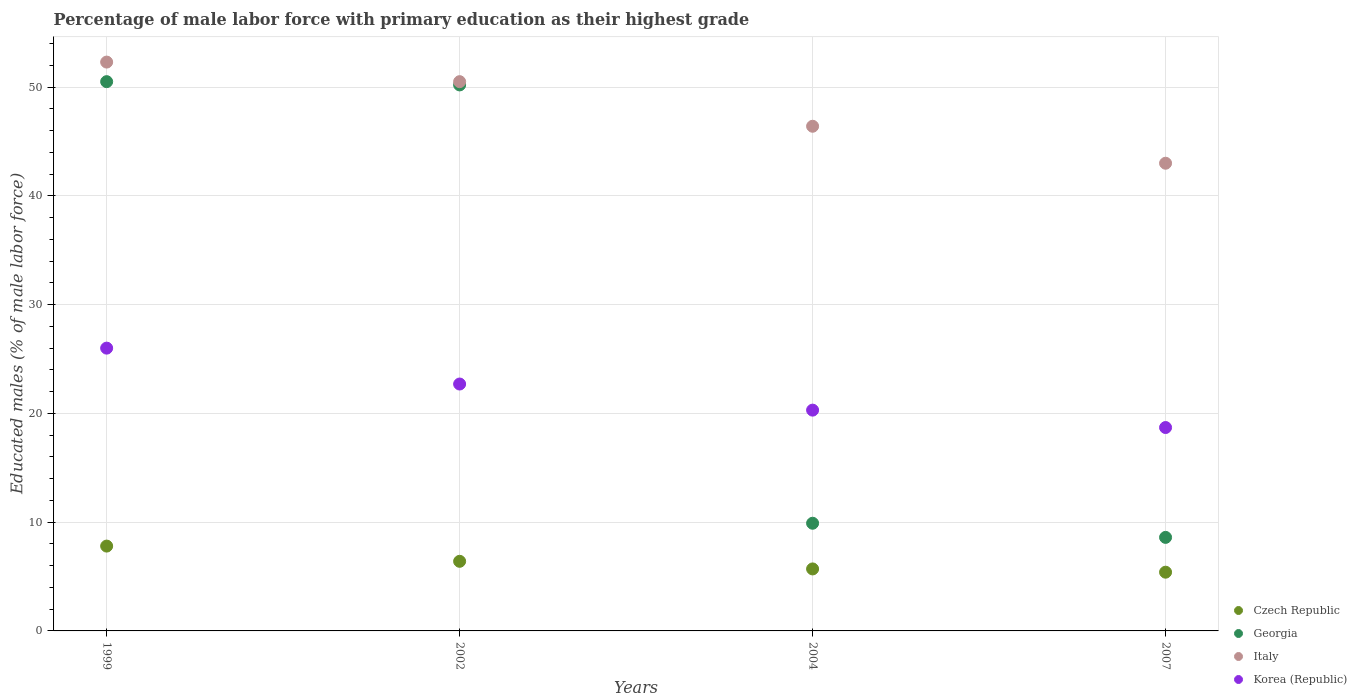How many different coloured dotlines are there?
Your response must be concise. 4. What is the percentage of male labor force with primary education in Czech Republic in 2004?
Give a very brief answer. 5.7. Across all years, what is the maximum percentage of male labor force with primary education in Italy?
Your answer should be compact. 52.3. Across all years, what is the minimum percentage of male labor force with primary education in Czech Republic?
Ensure brevity in your answer.  5.4. In which year was the percentage of male labor force with primary education in Italy minimum?
Give a very brief answer. 2007. What is the total percentage of male labor force with primary education in Korea (Republic) in the graph?
Ensure brevity in your answer.  87.7. What is the difference between the percentage of male labor force with primary education in Georgia in 2002 and that in 2004?
Give a very brief answer. 40.3. What is the difference between the percentage of male labor force with primary education in Czech Republic in 2004 and the percentage of male labor force with primary education in Korea (Republic) in 2007?
Keep it short and to the point. -13. What is the average percentage of male labor force with primary education in Italy per year?
Keep it short and to the point. 48.05. In the year 2004, what is the difference between the percentage of male labor force with primary education in Georgia and percentage of male labor force with primary education in Czech Republic?
Give a very brief answer. 4.2. What is the ratio of the percentage of male labor force with primary education in Italy in 1999 to that in 2002?
Provide a short and direct response. 1.04. What is the difference between the highest and the second highest percentage of male labor force with primary education in Italy?
Your answer should be very brief. 1.8. What is the difference between the highest and the lowest percentage of male labor force with primary education in Korea (Republic)?
Your answer should be compact. 7.3. In how many years, is the percentage of male labor force with primary education in Korea (Republic) greater than the average percentage of male labor force with primary education in Korea (Republic) taken over all years?
Your answer should be compact. 2. Does the percentage of male labor force with primary education in Italy monotonically increase over the years?
Offer a terse response. No. What is the difference between two consecutive major ticks on the Y-axis?
Your answer should be compact. 10. Are the values on the major ticks of Y-axis written in scientific E-notation?
Offer a very short reply. No. Does the graph contain grids?
Offer a very short reply. Yes. How many legend labels are there?
Offer a very short reply. 4. What is the title of the graph?
Keep it short and to the point. Percentage of male labor force with primary education as their highest grade. What is the label or title of the Y-axis?
Provide a succinct answer. Educated males (% of male labor force). What is the Educated males (% of male labor force) of Czech Republic in 1999?
Offer a very short reply. 7.8. What is the Educated males (% of male labor force) in Georgia in 1999?
Provide a succinct answer. 50.5. What is the Educated males (% of male labor force) in Italy in 1999?
Offer a terse response. 52.3. What is the Educated males (% of male labor force) in Czech Republic in 2002?
Offer a terse response. 6.4. What is the Educated males (% of male labor force) in Georgia in 2002?
Provide a short and direct response. 50.2. What is the Educated males (% of male labor force) of Italy in 2002?
Provide a succinct answer. 50.5. What is the Educated males (% of male labor force) in Korea (Republic) in 2002?
Provide a short and direct response. 22.7. What is the Educated males (% of male labor force) of Czech Republic in 2004?
Ensure brevity in your answer.  5.7. What is the Educated males (% of male labor force) of Georgia in 2004?
Your response must be concise. 9.9. What is the Educated males (% of male labor force) of Italy in 2004?
Offer a terse response. 46.4. What is the Educated males (% of male labor force) in Korea (Republic) in 2004?
Ensure brevity in your answer.  20.3. What is the Educated males (% of male labor force) of Czech Republic in 2007?
Your answer should be very brief. 5.4. What is the Educated males (% of male labor force) of Georgia in 2007?
Keep it short and to the point. 8.6. What is the Educated males (% of male labor force) in Korea (Republic) in 2007?
Offer a terse response. 18.7. Across all years, what is the maximum Educated males (% of male labor force) of Czech Republic?
Offer a terse response. 7.8. Across all years, what is the maximum Educated males (% of male labor force) in Georgia?
Keep it short and to the point. 50.5. Across all years, what is the maximum Educated males (% of male labor force) of Italy?
Offer a terse response. 52.3. Across all years, what is the maximum Educated males (% of male labor force) in Korea (Republic)?
Provide a succinct answer. 26. Across all years, what is the minimum Educated males (% of male labor force) in Czech Republic?
Provide a succinct answer. 5.4. Across all years, what is the minimum Educated males (% of male labor force) in Georgia?
Keep it short and to the point. 8.6. Across all years, what is the minimum Educated males (% of male labor force) in Italy?
Provide a short and direct response. 43. Across all years, what is the minimum Educated males (% of male labor force) of Korea (Republic)?
Your answer should be very brief. 18.7. What is the total Educated males (% of male labor force) of Czech Republic in the graph?
Your answer should be very brief. 25.3. What is the total Educated males (% of male labor force) of Georgia in the graph?
Your answer should be compact. 119.2. What is the total Educated males (% of male labor force) of Italy in the graph?
Your answer should be very brief. 192.2. What is the total Educated males (% of male labor force) in Korea (Republic) in the graph?
Your answer should be very brief. 87.7. What is the difference between the Educated males (% of male labor force) in Czech Republic in 1999 and that in 2002?
Make the answer very short. 1.4. What is the difference between the Educated males (% of male labor force) in Italy in 1999 and that in 2002?
Provide a short and direct response. 1.8. What is the difference between the Educated males (% of male labor force) of Korea (Republic) in 1999 and that in 2002?
Your answer should be compact. 3.3. What is the difference between the Educated males (% of male labor force) in Czech Republic in 1999 and that in 2004?
Make the answer very short. 2.1. What is the difference between the Educated males (% of male labor force) of Georgia in 1999 and that in 2004?
Your response must be concise. 40.6. What is the difference between the Educated males (% of male labor force) of Korea (Republic) in 1999 and that in 2004?
Provide a succinct answer. 5.7. What is the difference between the Educated males (% of male labor force) of Georgia in 1999 and that in 2007?
Provide a succinct answer. 41.9. What is the difference between the Educated males (% of male labor force) of Italy in 1999 and that in 2007?
Provide a short and direct response. 9.3. What is the difference between the Educated males (% of male labor force) in Korea (Republic) in 1999 and that in 2007?
Ensure brevity in your answer.  7.3. What is the difference between the Educated males (% of male labor force) of Czech Republic in 2002 and that in 2004?
Keep it short and to the point. 0.7. What is the difference between the Educated males (% of male labor force) in Georgia in 2002 and that in 2004?
Your response must be concise. 40.3. What is the difference between the Educated males (% of male labor force) in Italy in 2002 and that in 2004?
Provide a short and direct response. 4.1. What is the difference between the Educated males (% of male labor force) of Korea (Republic) in 2002 and that in 2004?
Provide a succinct answer. 2.4. What is the difference between the Educated males (% of male labor force) of Georgia in 2002 and that in 2007?
Offer a very short reply. 41.6. What is the difference between the Educated males (% of male labor force) in Czech Republic in 1999 and the Educated males (% of male labor force) in Georgia in 2002?
Give a very brief answer. -42.4. What is the difference between the Educated males (% of male labor force) in Czech Republic in 1999 and the Educated males (% of male labor force) in Italy in 2002?
Your response must be concise. -42.7. What is the difference between the Educated males (% of male labor force) of Czech Republic in 1999 and the Educated males (% of male labor force) of Korea (Republic) in 2002?
Ensure brevity in your answer.  -14.9. What is the difference between the Educated males (% of male labor force) of Georgia in 1999 and the Educated males (% of male labor force) of Korea (Republic) in 2002?
Provide a succinct answer. 27.8. What is the difference between the Educated males (% of male labor force) in Italy in 1999 and the Educated males (% of male labor force) in Korea (Republic) in 2002?
Offer a very short reply. 29.6. What is the difference between the Educated males (% of male labor force) of Czech Republic in 1999 and the Educated males (% of male labor force) of Georgia in 2004?
Give a very brief answer. -2.1. What is the difference between the Educated males (% of male labor force) of Czech Republic in 1999 and the Educated males (% of male labor force) of Italy in 2004?
Offer a very short reply. -38.6. What is the difference between the Educated males (% of male labor force) in Georgia in 1999 and the Educated males (% of male labor force) in Korea (Republic) in 2004?
Your response must be concise. 30.2. What is the difference between the Educated males (% of male labor force) of Czech Republic in 1999 and the Educated males (% of male labor force) of Italy in 2007?
Ensure brevity in your answer.  -35.2. What is the difference between the Educated males (% of male labor force) of Czech Republic in 1999 and the Educated males (% of male labor force) of Korea (Republic) in 2007?
Offer a terse response. -10.9. What is the difference between the Educated males (% of male labor force) in Georgia in 1999 and the Educated males (% of male labor force) in Korea (Republic) in 2007?
Your response must be concise. 31.8. What is the difference between the Educated males (% of male labor force) in Italy in 1999 and the Educated males (% of male labor force) in Korea (Republic) in 2007?
Your answer should be compact. 33.6. What is the difference between the Educated males (% of male labor force) in Czech Republic in 2002 and the Educated males (% of male labor force) in Italy in 2004?
Offer a terse response. -40. What is the difference between the Educated males (% of male labor force) of Czech Republic in 2002 and the Educated males (% of male labor force) of Korea (Republic) in 2004?
Give a very brief answer. -13.9. What is the difference between the Educated males (% of male labor force) of Georgia in 2002 and the Educated males (% of male labor force) of Italy in 2004?
Offer a terse response. 3.8. What is the difference between the Educated males (% of male labor force) in Georgia in 2002 and the Educated males (% of male labor force) in Korea (Republic) in 2004?
Your answer should be very brief. 29.9. What is the difference between the Educated males (% of male labor force) in Italy in 2002 and the Educated males (% of male labor force) in Korea (Republic) in 2004?
Offer a very short reply. 30.2. What is the difference between the Educated males (% of male labor force) of Czech Republic in 2002 and the Educated males (% of male labor force) of Italy in 2007?
Offer a terse response. -36.6. What is the difference between the Educated males (% of male labor force) in Czech Republic in 2002 and the Educated males (% of male labor force) in Korea (Republic) in 2007?
Keep it short and to the point. -12.3. What is the difference between the Educated males (% of male labor force) in Georgia in 2002 and the Educated males (% of male labor force) in Korea (Republic) in 2007?
Your answer should be compact. 31.5. What is the difference between the Educated males (% of male labor force) in Italy in 2002 and the Educated males (% of male labor force) in Korea (Republic) in 2007?
Offer a terse response. 31.8. What is the difference between the Educated males (% of male labor force) in Czech Republic in 2004 and the Educated males (% of male labor force) in Georgia in 2007?
Offer a very short reply. -2.9. What is the difference between the Educated males (% of male labor force) in Czech Republic in 2004 and the Educated males (% of male labor force) in Italy in 2007?
Keep it short and to the point. -37.3. What is the difference between the Educated males (% of male labor force) of Georgia in 2004 and the Educated males (% of male labor force) of Italy in 2007?
Offer a terse response. -33.1. What is the difference between the Educated males (% of male labor force) of Georgia in 2004 and the Educated males (% of male labor force) of Korea (Republic) in 2007?
Your answer should be compact. -8.8. What is the difference between the Educated males (% of male labor force) in Italy in 2004 and the Educated males (% of male labor force) in Korea (Republic) in 2007?
Offer a very short reply. 27.7. What is the average Educated males (% of male labor force) in Czech Republic per year?
Ensure brevity in your answer.  6.33. What is the average Educated males (% of male labor force) in Georgia per year?
Ensure brevity in your answer.  29.8. What is the average Educated males (% of male labor force) of Italy per year?
Offer a terse response. 48.05. What is the average Educated males (% of male labor force) in Korea (Republic) per year?
Provide a succinct answer. 21.93. In the year 1999, what is the difference between the Educated males (% of male labor force) of Czech Republic and Educated males (% of male labor force) of Georgia?
Make the answer very short. -42.7. In the year 1999, what is the difference between the Educated males (% of male labor force) of Czech Republic and Educated males (% of male labor force) of Italy?
Provide a succinct answer. -44.5. In the year 1999, what is the difference between the Educated males (% of male labor force) of Czech Republic and Educated males (% of male labor force) of Korea (Republic)?
Offer a very short reply. -18.2. In the year 1999, what is the difference between the Educated males (% of male labor force) in Georgia and Educated males (% of male labor force) in Italy?
Make the answer very short. -1.8. In the year 1999, what is the difference between the Educated males (% of male labor force) of Italy and Educated males (% of male labor force) of Korea (Republic)?
Your answer should be compact. 26.3. In the year 2002, what is the difference between the Educated males (% of male labor force) of Czech Republic and Educated males (% of male labor force) of Georgia?
Offer a terse response. -43.8. In the year 2002, what is the difference between the Educated males (% of male labor force) in Czech Republic and Educated males (% of male labor force) in Italy?
Ensure brevity in your answer.  -44.1. In the year 2002, what is the difference between the Educated males (% of male labor force) of Czech Republic and Educated males (% of male labor force) of Korea (Republic)?
Your response must be concise. -16.3. In the year 2002, what is the difference between the Educated males (% of male labor force) of Italy and Educated males (% of male labor force) of Korea (Republic)?
Offer a very short reply. 27.8. In the year 2004, what is the difference between the Educated males (% of male labor force) of Czech Republic and Educated males (% of male labor force) of Italy?
Your answer should be compact. -40.7. In the year 2004, what is the difference between the Educated males (% of male labor force) of Czech Republic and Educated males (% of male labor force) of Korea (Republic)?
Provide a succinct answer. -14.6. In the year 2004, what is the difference between the Educated males (% of male labor force) of Georgia and Educated males (% of male labor force) of Italy?
Make the answer very short. -36.5. In the year 2004, what is the difference between the Educated males (% of male labor force) in Georgia and Educated males (% of male labor force) in Korea (Republic)?
Provide a short and direct response. -10.4. In the year 2004, what is the difference between the Educated males (% of male labor force) of Italy and Educated males (% of male labor force) of Korea (Republic)?
Give a very brief answer. 26.1. In the year 2007, what is the difference between the Educated males (% of male labor force) in Czech Republic and Educated males (% of male labor force) in Italy?
Ensure brevity in your answer.  -37.6. In the year 2007, what is the difference between the Educated males (% of male labor force) of Georgia and Educated males (% of male labor force) of Italy?
Your answer should be compact. -34.4. In the year 2007, what is the difference between the Educated males (% of male labor force) of Georgia and Educated males (% of male labor force) of Korea (Republic)?
Your answer should be very brief. -10.1. In the year 2007, what is the difference between the Educated males (% of male labor force) of Italy and Educated males (% of male labor force) of Korea (Republic)?
Make the answer very short. 24.3. What is the ratio of the Educated males (% of male labor force) in Czech Republic in 1999 to that in 2002?
Your response must be concise. 1.22. What is the ratio of the Educated males (% of male labor force) in Georgia in 1999 to that in 2002?
Your answer should be compact. 1.01. What is the ratio of the Educated males (% of male labor force) of Italy in 1999 to that in 2002?
Your answer should be very brief. 1.04. What is the ratio of the Educated males (% of male labor force) of Korea (Republic) in 1999 to that in 2002?
Ensure brevity in your answer.  1.15. What is the ratio of the Educated males (% of male labor force) in Czech Republic in 1999 to that in 2004?
Offer a very short reply. 1.37. What is the ratio of the Educated males (% of male labor force) in Georgia in 1999 to that in 2004?
Give a very brief answer. 5.1. What is the ratio of the Educated males (% of male labor force) in Italy in 1999 to that in 2004?
Your answer should be very brief. 1.13. What is the ratio of the Educated males (% of male labor force) in Korea (Republic) in 1999 to that in 2004?
Provide a succinct answer. 1.28. What is the ratio of the Educated males (% of male labor force) in Czech Republic in 1999 to that in 2007?
Provide a short and direct response. 1.44. What is the ratio of the Educated males (% of male labor force) of Georgia in 1999 to that in 2007?
Make the answer very short. 5.87. What is the ratio of the Educated males (% of male labor force) of Italy in 1999 to that in 2007?
Offer a very short reply. 1.22. What is the ratio of the Educated males (% of male labor force) of Korea (Republic) in 1999 to that in 2007?
Provide a succinct answer. 1.39. What is the ratio of the Educated males (% of male labor force) of Czech Republic in 2002 to that in 2004?
Offer a terse response. 1.12. What is the ratio of the Educated males (% of male labor force) of Georgia in 2002 to that in 2004?
Keep it short and to the point. 5.07. What is the ratio of the Educated males (% of male labor force) of Italy in 2002 to that in 2004?
Offer a very short reply. 1.09. What is the ratio of the Educated males (% of male labor force) in Korea (Republic) in 2002 to that in 2004?
Provide a succinct answer. 1.12. What is the ratio of the Educated males (% of male labor force) in Czech Republic in 2002 to that in 2007?
Provide a succinct answer. 1.19. What is the ratio of the Educated males (% of male labor force) of Georgia in 2002 to that in 2007?
Offer a terse response. 5.84. What is the ratio of the Educated males (% of male labor force) of Italy in 2002 to that in 2007?
Provide a succinct answer. 1.17. What is the ratio of the Educated males (% of male labor force) in Korea (Republic) in 2002 to that in 2007?
Ensure brevity in your answer.  1.21. What is the ratio of the Educated males (% of male labor force) in Czech Republic in 2004 to that in 2007?
Offer a very short reply. 1.06. What is the ratio of the Educated males (% of male labor force) of Georgia in 2004 to that in 2007?
Ensure brevity in your answer.  1.15. What is the ratio of the Educated males (% of male labor force) of Italy in 2004 to that in 2007?
Make the answer very short. 1.08. What is the ratio of the Educated males (% of male labor force) in Korea (Republic) in 2004 to that in 2007?
Provide a short and direct response. 1.09. What is the difference between the highest and the second highest Educated males (% of male labor force) of Georgia?
Your response must be concise. 0.3. What is the difference between the highest and the second highest Educated males (% of male labor force) of Italy?
Your answer should be compact. 1.8. What is the difference between the highest and the second highest Educated males (% of male labor force) in Korea (Republic)?
Give a very brief answer. 3.3. What is the difference between the highest and the lowest Educated males (% of male labor force) in Czech Republic?
Give a very brief answer. 2.4. What is the difference between the highest and the lowest Educated males (% of male labor force) of Georgia?
Offer a terse response. 41.9. What is the difference between the highest and the lowest Educated males (% of male labor force) in Italy?
Keep it short and to the point. 9.3. 